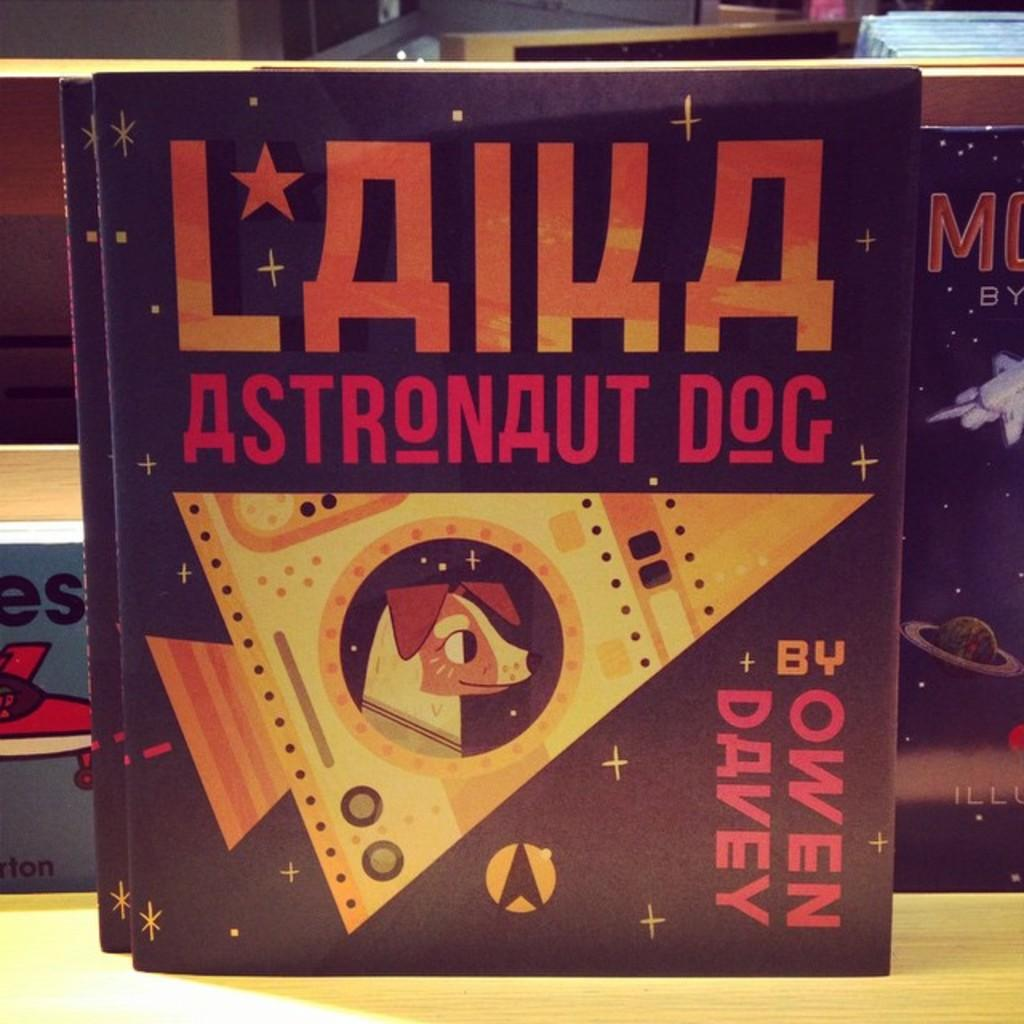<image>
Present a compact description of the photo's key features. The title of the book is Laika Astronaut dog is displayed. 